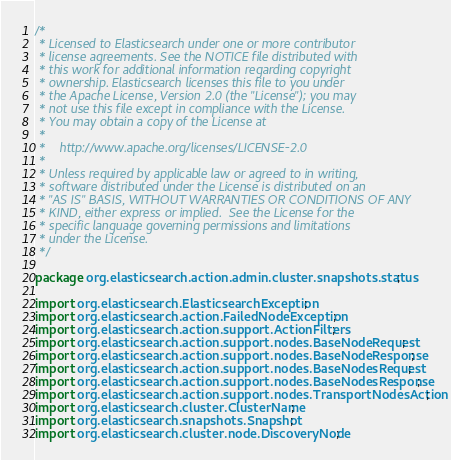<code> <loc_0><loc_0><loc_500><loc_500><_Java_>/*
 * Licensed to Elasticsearch under one or more contributor
 * license agreements. See the NOTICE file distributed with
 * this work for additional information regarding copyright
 * ownership. Elasticsearch licenses this file to you under
 * the Apache License, Version 2.0 (the "License"); you may
 * not use this file except in compliance with the License.
 * You may obtain a copy of the License at
 *
 *    http://www.apache.org/licenses/LICENSE-2.0
 *
 * Unless required by applicable law or agreed to in writing,
 * software distributed under the License is distributed on an
 * "AS IS" BASIS, WITHOUT WARRANTIES OR CONDITIONS OF ANY
 * KIND, either express or implied.  See the License for the
 * specific language governing permissions and limitations
 * under the License.
 */

package org.elasticsearch.action.admin.cluster.snapshots.status;

import org.elasticsearch.ElasticsearchException;
import org.elasticsearch.action.FailedNodeException;
import org.elasticsearch.action.support.ActionFilters;
import org.elasticsearch.action.support.nodes.BaseNodeRequest;
import org.elasticsearch.action.support.nodes.BaseNodeResponse;
import org.elasticsearch.action.support.nodes.BaseNodesRequest;
import org.elasticsearch.action.support.nodes.BaseNodesResponse;
import org.elasticsearch.action.support.nodes.TransportNodesAction;
import org.elasticsearch.cluster.ClusterName;
import org.elasticsearch.snapshots.Snapshot;
import org.elasticsearch.cluster.node.DiscoveryNode;</code> 